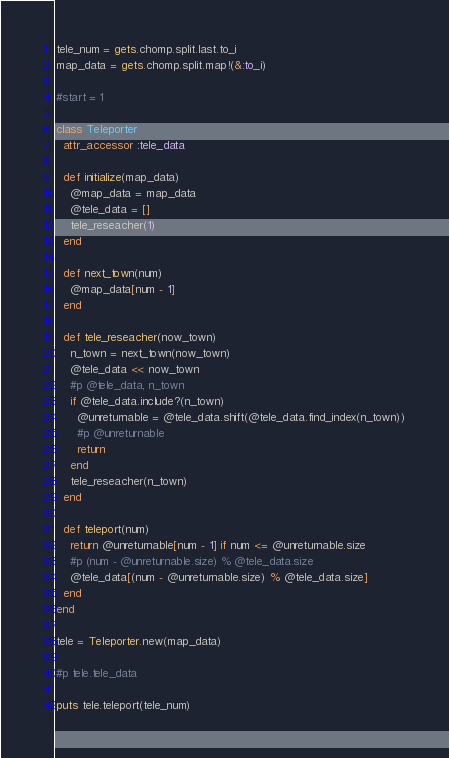<code> <loc_0><loc_0><loc_500><loc_500><_Ruby_>tele_num = gets.chomp.split.last.to_i
map_data = gets.chomp.split.map!(&:to_i)

#start = 1

class Teleporter
  attr_accessor :tele_data
  
  def initialize(map_data)
    @map_data = map_data
    @tele_data = []
    tele_reseacher(1)
  end
  
  def next_town(num)
  	@map_data[num - 1]
  end
  
  def tele_reseacher(now_town)
    n_town = next_town(now_town)
    @tele_data << now_town
    #p @tele_data, n_town
    if @tele_data.include?(n_town)
      @unreturnable = @tele_data.shift(@tele_data.find_index(n_town))
      #p @unreturnable
      return
    end
    tele_reseacher(n_town)
  end
  
  def teleport(num)
    return @unreturnable[num - 1] if num <= @unreturnable.size
    #p (num - @unreturnable.size) % @tele_data.size
    @tele_data[(num - @unreturnable.size) % @tele_data.size]
  end
end

tele = Teleporter.new(map_data)

#p tele.tele_data

puts tele.teleport(tele_num)</code> 